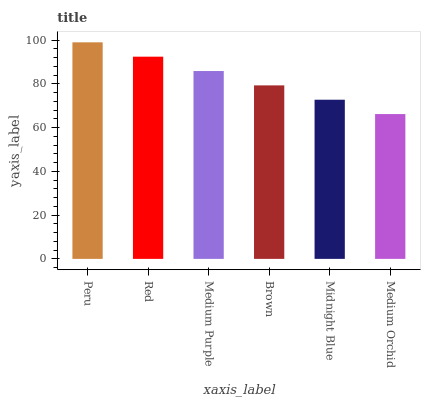Is Medium Orchid the minimum?
Answer yes or no. Yes. Is Peru the maximum?
Answer yes or no. Yes. Is Red the minimum?
Answer yes or no. No. Is Red the maximum?
Answer yes or no. No. Is Peru greater than Red?
Answer yes or no. Yes. Is Red less than Peru?
Answer yes or no. Yes. Is Red greater than Peru?
Answer yes or no. No. Is Peru less than Red?
Answer yes or no. No. Is Medium Purple the high median?
Answer yes or no. Yes. Is Brown the low median?
Answer yes or no. Yes. Is Medium Orchid the high median?
Answer yes or no. No. Is Midnight Blue the low median?
Answer yes or no. No. 